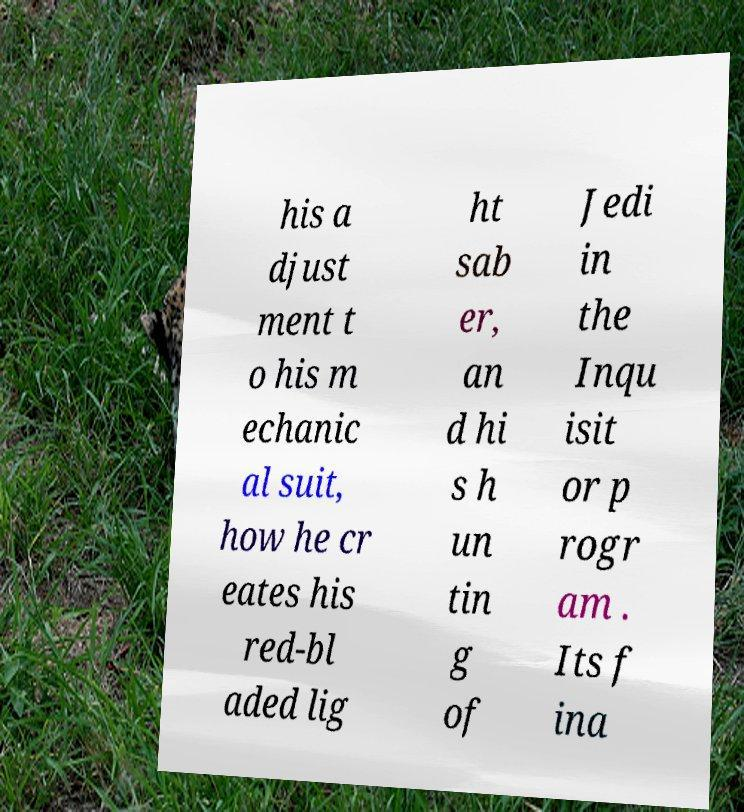What messages or text are displayed in this image? I need them in a readable, typed format. his a djust ment t o his m echanic al suit, how he cr eates his red-bl aded lig ht sab er, an d hi s h un tin g of Jedi in the Inqu isit or p rogr am . Its f ina 